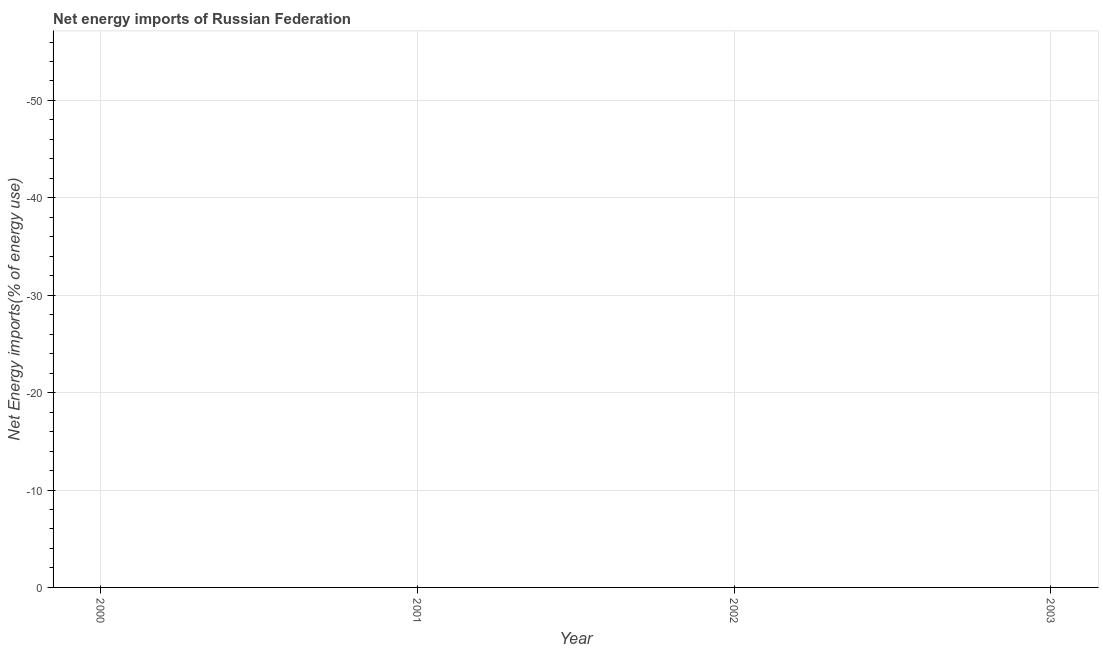What is the energy imports in 2002?
Your response must be concise. 0. Across all years, what is the minimum energy imports?
Offer a very short reply. 0. What is the sum of the energy imports?
Your answer should be very brief. 0. What is the average energy imports per year?
Ensure brevity in your answer.  0. What is the median energy imports?
Keep it short and to the point. 0. Does the energy imports monotonically increase over the years?
Ensure brevity in your answer.  No. How many years are there in the graph?
Keep it short and to the point. 4. Does the graph contain any zero values?
Your response must be concise. Yes. Does the graph contain grids?
Your answer should be compact. Yes. What is the title of the graph?
Your answer should be very brief. Net energy imports of Russian Federation. What is the label or title of the Y-axis?
Ensure brevity in your answer.  Net Energy imports(% of energy use). What is the Net Energy imports(% of energy use) in 2000?
Provide a succinct answer. 0. What is the Net Energy imports(% of energy use) in 2001?
Your answer should be very brief. 0. What is the Net Energy imports(% of energy use) in 2002?
Provide a short and direct response. 0. 